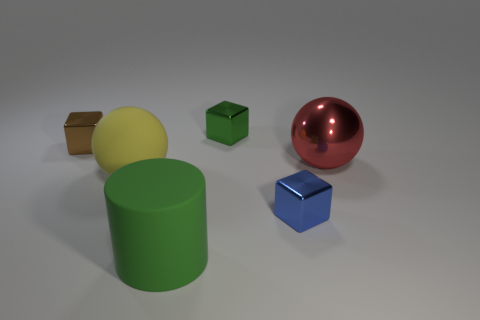Add 2 big objects. How many objects exist? 8 Subtract all cylinders. How many objects are left? 5 Subtract 0 green balls. How many objects are left? 6 Subtract all big cylinders. Subtract all small metal objects. How many objects are left? 2 Add 5 big matte things. How many big matte things are left? 7 Add 6 brown things. How many brown things exist? 7 